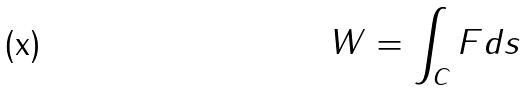<formula> <loc_0><loc_0><loc_500><loc_500>W = \int _ { C } F d s</formula> 